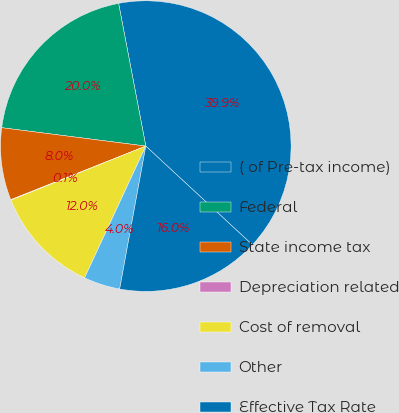Convert chart. <chart><loc_0><loc_0><loc_500><loc_500><pie_chart><fcel>( of Pre-tax income)<fcel>Federal<fcel>State income tax<fcel>Depreciation related<fcel>Cost of removal<fcel>Other<fcel>Effective Tax Rate<nl><fcel>39.89%<fcel>19.98%<fcel>8.03%<fcel>0.06%<fcel>12.01%<fcel>4.04%<fcel>15.99%<nl></chart> 